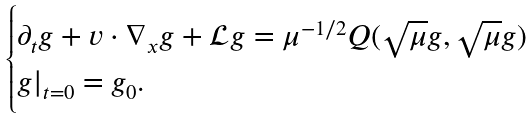<formula> <loc_0><loc_0><loc_500><loc_500>\begin{cases} \partial _ { t } g + v \cdot \nabla _ { x } g + \mathcal { L } g = \mu ^ { - 1 / 2 } Q ( \sqrt { \mu } g , \sqrt { \mu } g ) \\ g | _ { t = 0 } = g _ { 0 } . \end{cases}</formula> 